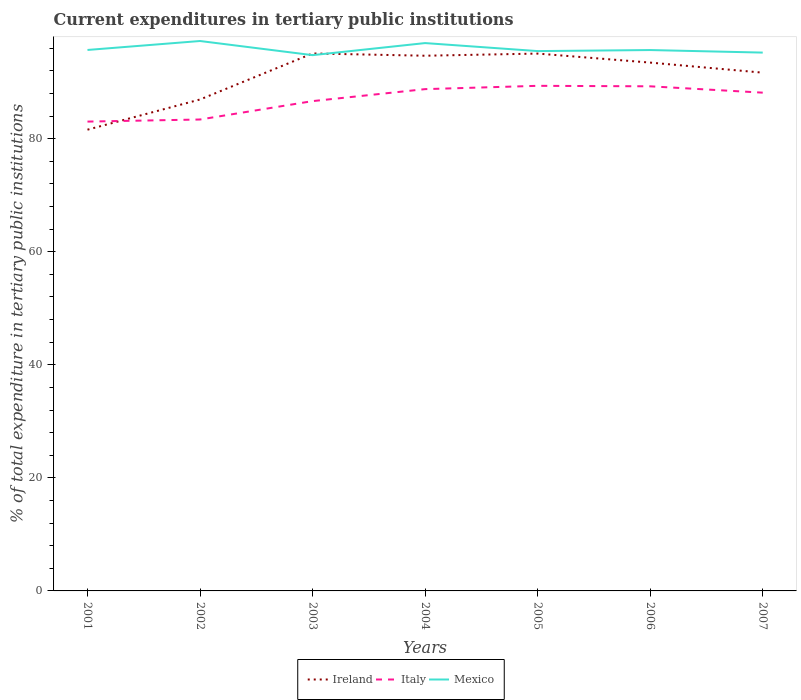How many different coloured lines are there?
Your answer should be compact. 3. Across all years, what is the maximum current expenditures in tertiary public institutions in Mexico?
Your response must be concise. 94.78. In which year was the current expenditures in tertiary public institutions in Ireland maximum?
Offer a very short reply. 2001. What is the total current expenditures in tertiary public institutions in Italy in the graph?
Give a very brief answer. -0.37. What is the difference between the highest and the second highest current expenditures in tertiary public institutions in Mexico?
Keep it short and to the point. 2.5. How many lines are there?
Your answer should be very brief. 3. What is the difference between two consecutive major ticks on the Y-axis?
Your answer should be compact. 20. Does the graph contain grids?
Offer a terse response. No. What is the title of the graph?
Offer a terse response. Current expenditures in tertiary public institutions. What is the label or title of the Y-axis?
Keep it short and to the point. % of total expenditure in tertiary public institutions. What is the % of total expenditure in tertiary public institutions in Ireland in 2001?
Your answer should be very brief. 81.6. What is the % of total expenditure in tertiary public institutions of Italy in 2001?
Your answer should be very brief. 83.03. What is the % of total expenditure in tertiary public institutions of Mexico in 2001?
Your answer should be compact. 95.7. What is the % of total expenditure in tertiary public institutions in Ireland in 2002?
Provide a short and direct response. 86.94. What is the % of total expenditure in tertiary public institutions in Italy in 2002?
Offer a terse response. 83.4. What is the % of total expenditure in tertiary public institutions in Mexico in 2002?
Give a very brief answer. 97.28. What is the % of total expenditure in tertiary public institutions of Ireland in 2003?
Give a very brief answer. 95.08. What is the % of total expenditure in tertiary public institutions in Italy in 2003?
Make the answer very short. 86.65. What is the % of total expenditure in tertiary public institutions of Mexico in 2003?
Give a very brief answer. 94.78. What is the % of total expenditure in tertiary public institutions of Ireland in 2004?
Keep it short and to the point. 94.68. What is the % of total expenditure in tertiary public institutions of Italy in 2004?
Ensure brevity in your answer.  88.77. What is the % of total expenditure in tertiary public institutions in Mexico in 2004?
Keep it short and to the point. 96.92. What is the % of total expenditure in tertiary public institutions in Ireland in 2005?
Make the answer very short. 95.06. What is the % of total expenditure in tertiary public institutions in Italy in 2005?
Offer a terse response. 89.36. What is the % of total expenditure in tertiary public institutions of Mexico in 2005?
Offer a very short reply. 95.5. What is the % of total expenditure in tertiary public institutions of Ireland in 2006?
Make the answer very short. 93.47. What is the % of total expenditure in tertiary public institutions in Italy in 2006?
Provide a short and direct response. 89.27. What is the % of total expenditure in tertiary public institutions in Mexico in 2006?
Offer a very short reply. 95.68. What is the % of total expenditure in tertiary public institutions in Ireland in 2007?
Give a very brief answer. 91.68. What is the % of total expenditure in tertiary public institutions of Italy in 2007?
Your answer should be very brief. 88.15. What is the % of total expenditure in tertiary public institutions of Mexico in 2007?
Make the answer very short. 95.23. Across all years, what is the maximum % of total expenditure in tertiary public institutions in Ireland?
Your answer should be compact. 95.08. Across all years, what is the maximum % of total expenditure in tertiary public institutions in Italy?
Give a very brief answer. 89.36. Across all years, what is the maximum % of total expenditure in tertiary public institutions in Mexico?
Give a very brief answer. 97.28. Across all years, what is the minimum % of total expenditure in tertiary public institutions of Ireland?
Make the answer very short. 81.6. Across all years, what is the minimum % of total expenditure in tertiary public institutions of Italy?
Ensure brevity in your answer.  83.03. Across all years, what is the minimum % of total expenditure in tertiary public institutions in Mexico?
Your answer should be compact. 94.78. What is the total % of total expenditure in tertiary public institutions of Ireland in the graph?
Your response must be concise. 638.51. What is the total % of total expenditure in tertiary public institutions in Italy in the graph?
Provide a short and direct response. 608.62. What is the total % of total expenditure in tertiary public institutions in Mexico in the graph?
Provide a succinct answer. 671.1. What is the difference between the % of total expenditure in tertiary public institutions of Ireland in 2001 and that in 2002?
Keep it short and to the point. -5.34. What is the difference between the % of total expenditure in tertiary public institutions in Italy in 2001 and that in 2002?
Your response must be concise. -0.37. What is the difference between the % of total expenditure in tertiary public institutions of Mexico in 2001 and that in 2002?
Your answer should be compact. -1.58. What is the difference between the % of total expenditure in tertiary public institutions of Ireland in 2001 and that in 2003?
Keep it short and to the point. -13.49. What is the difference between the % of total expenditure in tertiary public institutions of Italy in 2001 and that in 2003?
Ensure brevity in your answer.  -3.62. What is the difference between the % of total expenditure in tertiary public institutions of Mexico in 2001 and that in 2003?
Keep it short and to the point. 0.92. What is the difference between the % of total expenditure in tertiary public institutions in Ireland in 2001 and that in 2004?
Your response must be concise. -13.08. What is the difference between the % of total expenditure in tertiary public institutions of Italy in 2001 and that in 2004?
Offer a very short reply. -5.74. What is the difference between the % of total expenditure in tertiary public institutions in Mexico in 2001 and that in 2004?
Give a very brief answer. -1.22. What is the difference between the % of total expenditure in tertiary public institutions of Ireland in 2001 and that in 2005?
Offer a very short reply. -13.46. What is the difference between the % of total expenditure in tertiary public institutions in Italy in 2001 and that in 2005?
Ensure brevity in your answer.  -6.33. What is the difference between the % of total expenditure in tertiary public institutions in Mexico in 2001 and that in 2005?
Your answer should be very brief. 0.2. What is the difference between the % of total expenditure in tertiary public institutions in Ireland in 2001 and that in 2006?
Keep it short and to the point. -11.87. What is the difference between the % of total expenditure in tertiary public institutions of Italy in 2001 and that in 2006?
Offer a very short reply. -6.24. What is the difference between the % of total expenditure in tertiary public institutions of Mexico in 2001 and that in 2006?
Keep it short and to the point. 0.02. What is the difference between the % of total expenditure in tertiary public institutions in Ireland in 2001 and that in 2007?
Your answer should be very brief. -10.09. What is the difference between the % of total expenditure in tertiary public institutions of Italy in 2001 and that in 2007?
Provide a short and direct response. -5.12. What is the difference between the % of total expenditure in tertiary public institutions in Mexico in 2001 and that in 2007?
Your answer should be very brief. 0.47. What is the difference between the % of total expenditure in tertiary public institutions in Ireland in 2002 and that in 2003?
Your answer should be very brief. -8.14. What is the difference between the % of total expenditure in tertiary public institutions of Italy in 2002 and that in 2003?
Your response must be concise. -3.25. What is the difference between the % of total expenditure in tertiary public institutions in Mexico in 2002 and that in 2003?
Give a very brief answer. 2.5. What is the difference between the % of total expenditure in tertiary public institutions in Ireland in 2002 and that in 2004?
Provide a succinct answer. -7.74. What is the difference between the % of total expenditure in tertiary public institutions of Italy in 2002 and that in 2004?
Provide a succinct answer. -5.37. What is the difference between the % of total expenditure in tertiary public institutions of Mexico in 2002 and that in 2004?
Offer a terse response. 0.37. What is the difference between the % of total expenditure in tertiary public institutions in Ireland in 2002 and that in 2005?
Your answer should be very brief. -8.12. What is the difference between the % of total expenditure in tertiary public institutions of Italy in 2002 and that in 2005?
Ensure brevity in your answer.  -5.96. What is the difference between the % of total expenditure in tertiary public institutions of Mexico in 2002 and that in 2005?
Ensure brevity in your answer.  1.78. What is the difference between the % of total expenditure in tertiary public institutions of Ireland in 2002 and that in 2006?
Your response must be concise. -6.53. What is the difference between the % of total expenditure in tertiary public institutions in Italy in 2002 and that in 2006?
Offer a terse response. -5.87. What is the difference between the % of total expenditure in tertiary public institutions of Mexico in 2002 and that in 2006?
Your response must be concise. 1.6. What is the difference between the % of total expenditure in tertiary public institutions in Ireland in 2002 and that in 2007?
Provide a short and direct response. -4.74. What is the difference between the % of total expenditure in tertiary public institutions of Italy in 2002 and that in 2007?
Your response must be concise. -4.75. What is the difference between the % of total expenditure in tertiary public institutions of Mexico in 2002 and that in 2007?
Offer a very short reply. 2.05. What is the difference between the % of total expenditure in tertiary public institutions in Ireland in 2003 and that in 2004?
Provide a short and direct response. 0.4. What is the difference between the % of total expenditure in tertiary public institutions of Italy in 2003 and that in 2004?
Ensure brevity in your answer.  -2.12. What is the difference between the % of total expenditure in tertiary public institutions of Mexico in 2003 and that in 2004?
Your response must be concise. -2.13. What is the difference between the % of total expenditure in tertiary public institutions of Ireland in 2003 and that in 2005?
Provide a succinct answer. 0.02. What is the difference between the % of total expenditure in tertiary public institutions of Italy in 2003 and that in 2005?
Make the answer very short. -2.7. What is the difference between the % of total expenditure in tertiary public institutions of Mexico in 2003 and that in 2005?
Keep it short and to the point. -0.72. What is the difference between the % of total expenditure in tertiary public institutions in Ireland in 2003 and that in 2006?
Make the answer very short. 1.62. What is the difference between the % of total expenditure in tertiary public institutions of Italy in 2003 and that in 2006?
Give a very brief answer. -2.62. What is the difference between the % of total expenditure in tertiary public institutions in Mexico in 2003 and that in 2006?
Offer a terse response. -0.9. What is the difference between the % of total expenditure in tertiary public institutions in Ireland in 2003 and that in 2007?
Keep it short and to the point. 3.4. What is the difference between the % of total expenditure in tertiary public institutions of Italy in 2003 and that in 2007?
Your response must be concise. -1.5. What is the difference between the % of total expenditure in tertiary public institutions in Mexico in 2003 and that in 2007?
Keep it short and to the point. -0.45. What is the difference between the % of total expenditure in tertiary public institutions in Ireland in 2004 and that in 2005?
Your answer should be compact. -0.38. What is the difference between the % of total expenditure in tertiary public institutions of Italy in 2004 and that in 2005?
Ensure brevity in your answer.  -0.59. What is the difference between the % of total expenditure in tertiary public institutions of Mexico in 2004 and that in 2005?
Keep it short and to the point. 1.42. What is the difference between the % of total expenditure in tertiary public institutions of Ireland in 2004 and that in 2006?
Ensure brevity in your answer.  1.21. What is the difference between the % of total expenditure in tertiary public institutions of Italy in 2004 and that in 2006?
Your answer should be compact. -0.5. What is the difference between the % of total expenditure in tertiary public institutions in Mexico in 2004 and that in 2006?
Your answer should be compact. 1.23. What is the difference between the % of total expenditure in tertiary public institutions of Ireland in 2004 and that in 2007?
Give a very brief answer. 3. What is the difference between the % of total expenditure in tertiary public institutions of Italy in 2004 and that in 2007?
Offer a very short reply. 0.62. What is the difference between the % of total expenditure in tertiary public institutions in Mexico in 2004 and that in 2007?
Provide a short and direct response. 1.68. What is the difference between the % of total expenditure in tertiary public institutions in Ireland in 2005 and that in 2006?
Keep it short and to the point. 1.59. What is the difference between the % of total expenditure in tertiary public institutions of Italy in 2005 and that in 2006?
Your answer should be compact. 0.09. What is the difference between the % of total expenditure in tertiary public institutions of Mexico in 2005 and that in 2006?
Your answer should be very brief. -0.18. What is the difference between the % of total expenditure in tertiary public institutions in Ireland in 2005 and that in 2007?
Ensure brevity in your answer.  3.38. What is the difference between the % of total expenditure in tertiary public institutions of Italy in 2005 and that in 2007?
Offer a very short reply. 1.21. What is the difference between the % of total expenditure in tertiary public institutions in Mexico in 2005 and that in 2007?
Offer a very short reply. 0.27. What is the difference between the % of total expenditure in tertiary public institutions in Ireland in 2006 and that in 2007?
Your answer should be very brief. 1.78. What is the difference between the % of total expenditure in tertiary public institutions in Italy in 2006 and that in 2007?
Provide a short and direct response. 1.12. What is the difference between the % of total expenditure in tertiary public institutions of Mexico in 2006 and that in 2007?
Your response must be concise. 0.45. What is the difference between the % of total expenditure in tertiary public institutions of Ireland in 2001 and the % of total expenditure in tertiary public institutions of Italy in 2002?
Offer a terse response. -1.8. What is the difference between the % of total expenditure in tertiary public institutions in Ireland in 2001 and the % of total expenditure in tertiary public institutions in Mexico in 2002?
Your answer should be compact. -15.69. What is the difference between the % of total expenditure in tertiary public institutions in Italy in 2001 and the % of total expenditure in tertiary public institutions in Mexico in 2002?
Provide a short and direct response. -14.26. What is the difference between the % of total expenditure in tertiary public institutions of Ireland in 2001 and the % of total expenditure in tertiary public institutions of Italy in 2003?
Your answer should be compact. -5.05. What is the difference between the % of total expenditure in tertiary public institutions of Ireland in 2001 and the % of total expenditure in tertiary public institutions of Mexico in 2003?
Give a very brief answer. -13.19. What is the difference between the % of total expenditure in tertiary public institutions in Italy in 2001 and the % of total expenditure in tertiary public institutions in Mexico in 2003?
Make the answer very short. -11.76. What is the difference between the % of total expenditure in tertiary public institutions in Ireland in 2001 and the % of total expenditure in tertiary public institutions in Italy in 2004?
Your answer should be compact. -7.17. What is the difference between the % of total expenditure in tertiary public institutions of Ireland in 2001 and the % of total expenditure in tertiary public institutions of Mexico in 2004?
Your response must be concise. -15.32. What is the difference between the % of total expenditure in tertiary public institutions of Italy in 2001 and the % of total expenditure in tertiary public institutions of Mexico in 2004?
Keep it short and to the point. -13.89. What is the difference between the % of total expenditure in tertiary public institutions of Ireland in 2001 and the % of total expenditure in tertiary public institutions of Italy in 2005?
Your response must be concise. -7.76. What is the difference between the % of total expenditure in tertiary public institutions in Ireland in 2001 and the % of total expenditure in tertiary public institutions in Mexico in 2005?
Give a very brief answer. -13.9. What is the difference between the % of total expenditure in tertiary public institutions in Italy in 2001 and the % of total expenditure in tertiary public institutions in Mexico in 2005?
Your response must be concise. -12.47. What is the difference between the % of total expenditure in tertiary public institutions in Ireland in 2001 and the % of total expenditure in tertiary public institutions in Italy in 2006?
Offer a very short reply. -7.67. What is the difference between the % of total expenditure in tertiary public institutions of Ireland in 2001 and the % of total expenditure in tertiary public institutions of Mexico in 2006?
Ensure brevity in your answer.  -14.09. What is the difference between the % of total expenditure in tertiary public institutions of Italy in 2001 and the % of total expenditure in tertiary public institutions of Mexico in 2006?
Provide a short and direct response. -12.66. What is the difference between the % of total expenditure in tertiary public institutions of Ireland in 2001 and the % of total expenditure in tertiary public institutions of Italy in 2007?
Provide a succinct answer. -6.55. What is the difference between the % of total expenditure in tertiary public institutions of Ireland in 2001 and the % of total expenditure in tertiary public institutions of Mexico in 2007?
Provide a succinct answer. -13.64. What is the difference between the % of total expenditure in tertiary public institutions in Italy in 2001 and the % of total expenditure in tertiary public institutions in Mexico in 2007?
Offer a very short reply. -12.21. What is the difference between the % of total expenditure in tertiary public institutions of Ireland in 2002 and the % of total expenditure in tertiary public institutions of Italy in 2003?
Your answer should be very brief. 0.29. What is the difference between the % of total expenditure in tertiary public institutions of Ireland in 2002 and the % of total expenditure in tertiary public institutions of Mexico in 2003?
Ensure brevity in your answer.  -7.84. What is the difference between the % of total expenditure in tertiary public institutions in Italy in 2002 and the % of total expenditure in tertiary public institutions in Mexico in 2003?
Your response must be concise. -11.39. What is the difference between the % of total expenditure in tertiary public institutions of Ireland in 2002 and the % of total expenditure in tertiary public institutions of Italy in 2004?
Give a very brief answer. -1.83. What is the difference between the % of total expenditure in tertiary public institutions in Ireland in 2002 and the % of total expenditure in tertiary public institutions in Mexico in 2004?
Your answer should be very brief. -9.98. What is the difference between the % of total expenditure in tertiary public institutions of Italy in 2002 and the % of total expenditure in tertiary public institutions of Mexico in 2004?
Provide a short and direct response. -13.52. What is the difference between the % of total expenditure in tertiary public institutions in Ireland in 2002 and the % of total expenditure in tertiary public institutions in Italy in 2005?
Give a very brief answer. -2.42. What is the difference between the % of total expenditure in tertiary public institutions of Ireland in 2002 and the % of total expenditure in tertiary public institutions of Mexico in 2005?
Make the answer very short. -8.56. What is the difference between the % of total expenditure in tertiary public institutions in Italy in 2002 and the % of total expenditure in tertiary public institutions in Mexico in 2005?
Keep it short and to the point. -12.1. What is the difference between the % of total expenditure in tertiary public institutions in Ireland in 2002 and the % of total expenditure in tertiary public institutions in Italy in 2006?
Your response must be concise. -2.33. What is the difference between the % of total expenditure in tertiary public institutions in Ireland in 2002 and the % of total expenditure in tertiary public institutions in Mexico in 2006?
Keep it short and to the point. -8.74. What is the difference between the % of total expenditure in tertiary public institutions of Italy in 2002 and the % of total expenditure in tertiary public institutions of Mexico in 2006?
Keep it short and to the point. -12.29. What is the difference between the % of total expenditure in tertiary public institutions of Ireland in 2002 and the % of total expenditure in tertiary public institutions of Italy in 2007?
Ensure brevity in your answer.  -1.21. What is the difference between the % of total expenditure in tertiary public institutions of Ireland in 2002 and the % of total expenditure in tertiary public institutions of Mexico in 2007?
Your answer should be compact. -8.29. What is the difference between the % of total expenditure in tertiary public institutions in Italy in 2002 and the % of total expenditure in tertiary public institutions in Mexico in 2007?
Make the answer very short. -11.84. What is the difference between the % of total expenditure in tertiary public institutions in Ireland in 2003 and the % of total expenditure in tertiary public institutions in Italy in 2004?
Keep it short and to the point. 6.31. What is the difference between the % of total expenditure in tertiary public institutions in Ireland in 2003 and the % of total expenditure in tertiary public institutions in Mexico in 2004?
Your answer should be very brief. -1.84. What is the difference between the % of total expenditure in tertiary public institutions in Italy in 2003 and the % of total expenditure in tertiary public institutions in Mexico in 2004?
Your answer should be compact. -10.27. What is the difference between the % of total expenditure in tertiary public institutions of Ireland in 2003 and the % of total expenditure in tertiary public institutions of Italy in 2005?
Ensure brevity in your answer.  5.73. What is the difference between the % of total expenditure in tertiary public institutions in Ireland in 2003 and the % of total expenditure in tertiary public institutions in Mexico in 2005?
Your answer should be compact. -0.42. What is the difference between the % of total expenditure in tertiary public institutions of Italy in 2003 and the % of total expenditure in tertiary public institutions of Mexico in 2005?
Offer a terse response. -8.85. What is the difference between the % of total expenditure in tertiary public institutions in Ireland in 2003 and the % of total expenditure in tertiary public institutions in Italy in 2006?
Offer a very short reply. 5.81. What is the difference between the % of total expenditure in tertiary public institutions of Ireland in 2003 and the % of total expenditure in tertiary public institutions of Mexico in 2006?
Your answer should be very brief. -0.6. What is the difference between the % of total expenditure in tertiary public institutions of Italy in 2003 and the % of total expenditure in tertiary public institutions of Mexico in 2006?
Ensure brevity in your answer.  -9.03. What is the difference between the % of total expenditure in tertiary public institutions of Ireland in 2003 and the % of total expenditure in tertiary public institutions of Italy in 2007?
Provide a short and direct response. 6.93. What is the difference between the % of total expenditure in tertiary public institutions of Ireland in 2003 and the % of total expenditure in tertiary public institutions of Mexico in 2007?
Provide a short and direct response. -0.15. What is the difference between the % of total expenditure in tertiary public institutions in Italy in 2003 and the % of total expenditure in tertiary public institutions in Mexico in 2007?
Offer a very short reply. -8.58. What is the difference between the % of total expenditure in tertiary public institutions of Ireland in 2004 and the % of total expenditure in tertiary public institutions of Italy in 2005?
Your answer should be very brief. 5.32. What is the difference between the % of total expenditure in tertiary public institutions in Ireland in 2004 and the % of total expenditure in tertiary public institutions in Mexico in 2005?
Provide a short and direct response. -0.82. What is the difference between the % of total expenditure in tertiary public institutions of Italy in 2004 and the % of total expenditure in tertiary public institutions of Mexico in 2005?
Ensure brevity in your answer.  -6.73. What is the difference between the % of total expenditure in tertiary public institutions of Ireland in 2004 and the % of total expenditure in tertiary public institutions of Italy in 2006?
Provide a succinct answer. 5.41. What is the difference between the % of total expenditure in tertiary public institutions of Ireland in 2004 and the % of total expenditure in tertiary public institutions of Mexico in 2006?
Your response must be concise. -1. What is the difference between the % of total expenditure in tertiary public institutions in Italy in 2004 and the % of total expenditure in tertiary public institutions in Mexico in 2006?
Offer a very short reply. -6.91. What is the difference between the % of total expenditure in tertiary public institutions in Ireland in 2004 and the % of total expenditure in tertiary public institutions in Italy in 2007?
Provide a succinct answer. 6.53. What is the difference between the % of total expenditure in tertiary public institutions in Ireland in 2004 and the % of total expenditure in tertiary public institutions in Mexico in 2007?
Keep it short and to the point. -0.55. What is the difference between the % of total expenditure in tertiary public institutions of Italy in 2004 and the % of total expenditure in tertiary public institutions of Mexico in 2007?
Your response must be concise. -6.46. What is the difference between the % of total expenditure in tertiary public institutions of Ireland in 2005 and the % of total expenditure in tertiary public institutions of Italy in 2006?
Provide a short and direct response. 5.79. What is the difference between the % of total expenditure in tertiary public institutions in Ireland in 2005 and the % of total expenditure in tertiary public institutions in Mexico in 2006?
Keep it short and to the point. -0.62. What is the difference between the % of total expenditure in tertiary public institutions of Italy in 2005 and the % of total expenditure in tertiary public institutions of Mexico in 2006?
Offer a terse response. -6.33. What is the difference between the % of total expenditure in tertiary public institutions in Ireland in 2005 and the % of total expenditure in tertiary public institutions in Italy in 2007?
Keep it short and to the point. 6.91. What is the difference between the % of total expenditure in tertiary public institutions in Ireland in 2005 and the % of total expenditure in tertiary public institutions in Mexico in 2007?
Ensure brevity in your answer.  -0.17. What is the difference between the % of total expenditure in tertiary public institutions of Italy in 2005 and the % of total expenditure in tertiary public institutions of Mexico in 2007?
Offer a terse response. -5.88. What is the difference between the % of total expenditure in tertiary public institutions in Ireland in 2006 and the % of total expenditure in tertiary public institutions in Italy in 2007?
Give a very brief answer. 5.32. What is the difference between the % of total expenditure in tertiary public institutions in Ireland in 2006 and the % of total expenditure in tertiary public institutions in Mexico in 2007?
Offer a terse response. -1.77. What is the difference between the % of total expenditure in tertiary public institutions in Italy in 2006 and the % of total expenditure in tertiary public institutions in Mexico in 2007?
Keep it short and to the point. -5.97. What is the average % of total expenditure in tertiary public institutions in Ireland per year?
Ensure brevity in your answer.  91.22. What is the average % of total expenditure in tertiary public institutions of Italy per year?
Offer a very short reply. 86.95. What is the average % of total expenditure in tertiary public institutions of Mexico per year?
Provide a succinct answer. 95.87. In the year 2001, what is the difference between the % of total expenditure in tertiary public institutions of Ireland and % of total expenditure in tertiary public institutions of Italy?
Make the answer very short. -1.43. In the year 2001, what is the difference between the % of total expenditure in tertiary public institutions in Ireland and % of total expenditure in tertiary public institutions in Mexico?
Provide a succinct answer. -14.1. In the year 2001, what is the difference between the % of total expenditure in tertiary public institutions in Italy and % of total expenditure in tertiary public institutions in Mexico?
Offer a terse response. -12.67. In the year 2002, what is the difference between the % of total expenditure in tertiary public institutions of Ireland and % of total expenditure in tertiary public institutions of Italy?
Offer a terse response. 3.54. In the year 2002, what is the difference between the % of total expenditure in tertiary public institutions in Ireland and % of total expenditure in tertiary public institutions in Mexico?
Ensure brevity in your answer.  -10.34. In the year 2002, what is the difference between the % of total expenditure in tertiary public institutions of Italy and % of total expenditure in tertiary public institutions of Mexico?
Provide a short and direct response. -13.89. In the year 2003, what is the difference between the % of total expenditure in tertiary public institutions of Ireland and % of total expenditure in tertiary public institutions of Italy?
Give a very brief answer. 8.43. In the year 2003, what is the difference between the % of total expenditure in tertiary public institutions in Ireland and % of total expenditure in tertiary public institutions in Mexico?
Offer a very short reply. 0.3. In the year 2003, what is the difference between the % of total expenditure in tertiary public institutions of Italy and % of total expenditure in tertiary public institutions of Mexico?
Your answer should be compact. -8.13. In the year 2004, what is the difference between the % of total expenditure in tertiary public institutions in Ireland and % of total expenditure in tertiary public institutions in Italy?
Your response must be concise. 5.91. In the year 2004, what is the difference between the % of total expenditure in tertiary public institutions of Ireland and % of total expenditure in tertiary public institutions of Mexico?
Offer a very short reply. -2.24. In the year 2004, what is the difference between the % of total expenditure in tertiary public institutions in Italy and % of total expenditure in tertiary public institutions in Mexico?
Provide a succinct answer. -8.15. In the year 2005, what is the difference between the % of total expenditure in tertiary public institutions of Ireland and % of total expenditure in tertiary public institutions of Italy?
Provide a short and direct response. 5.7. In the year 2005, what is the difference between the % of total expenditure in tertiary public institutions of Ireland and % of total expenditure in tertiary public institutions of Mexico?
Keep it short and to the point. -0.44. In the year 2005, what is the difference between the % of total expenditure in tertiary public institutions of Italy and % of total expenditure in tertiary public institutions of Mexico?
Ensure brevity in your answer.  -6.14. In the year 2006, what is the difference between the % of total expenditure in tertiary public institutions in Ireland and % of total expenditure in tertiary public institutions in Italy?
Your response must be concise. 4.2. In the year 2006, what is the difference between the % of total expenditure in tertiary public institutions of Ireland and % of total expenditure in tertiary public institutions of Mexico?
Provide a short and direct response. -2.22. In the year 2006, what is the difference between the % of total expenditure in tertiary public institutions of Italy and % of total expenditure in tertiary public institutions of Mexico?
Your answer should be very brief. -6.41. In the year 2007, what is the difference between the % of total expenditure in tertiary public institutions of Ireland and % of total expenditure in tertiary public institutions of Italy?
Give a very brief answer. 3.54. In the year 2007, what is the difference between the % of total expenditure in tertiary public institutions of Ireland and % of total expenditure in tertiary public institutions of Mexico?
Offer a very short reply. -3.55. In the year 2007, what is the difference between the % of total expenditure in tertiary public institutions of Italy and % of total expenditure in tertiary public institutions of Mexico?
Offer a very short reply. -7.09. What is the ratio of the % of total expenditure in tertiary public institutions in Ireland in 2001 to that in 2002?
Your answer should be very brief. 0.94. What is the ratio of the % of total expenditure in tertiary public institutions of Italy in 2001 to that in 2002?
Ensure brevity in your answer.  1. What is the ratio of the % of total expenditure in tertiary public institutions of Mexico in 2001 to that in 2002?
Offer a very short reply. 0.98. What is the ratio of the % of total expenditure in tertiary public institutions of Ireland in 2001 to that in 2003?
Provide a succinct answer. 0.86. What is the ratio of the % of total expenditure in tertiary public institutions of Italy in 2001 to that in 2003?
Provide a succinct answer. 0.96. What is the ratio of the % of total expenditure in tertiary public institutions of Mexico in 2001 to that in 2003?
Make the answer very short. 1.01. What is the ratio of the % of total expenditure in tertiary public institutions of Ireland in 2001 to that in 2004?
Offer a terse response. 0.86. What is the ratio of the % of total expenditure in tertiary public institutions of Italy in 2001 to that in 2004?
Your answer should be very brief. 0.94. What is the ratio of the % of total expenditure in tertiary public institutions in Mexico in 2001 to that in 2004?
Ensure brevity in your answer.  0.99. What is the ratio of the % of total expenditure in tertiary public institutions in Ireland in 2001 to that in 2005?
Provide a succinct answer. 0.86. What is the ratio of the % of total expenditure in tertiary public institutions of Italy in 2001 to that in 2005?
Offer a terse response. 0.93. What is the ratio of the % of total expenditure in tertiary public institutions of Ireland in 2001 to that in 2006?
Offer a terse response. 0.87. What is the ratio of the % of total expenditure in tertiary public institutions in Italy in 2001 to that in 2006?
Make the answer very short. 0.93. What is the ratio of the % of total expenditure in tertiary public institutions in Ireland in 2001 to that in 2007?
Provide a short and direct response. 0.89. What is the ratio of the % of total expenditure in tertiary public institutions in Italy in 2001 to that in 2007?
Make the answer very short. 0.94. What is the ratio of the % of total expenditure in tertiary public institutions of Ireland in 2002 to that in 2003?
Your answer should be very brief. 0.91. What is the ratio of the % of total expenditure in tertiary public institutions in Italy in 2002 to that in 2003?
Give a very brief answer. 0.96. What is the ratio of the % of total expenditure in tertiary public institutions of Mexico in 2002 to that in 2003?
Your answer should be compact. 1.03. What is the ratio of the % of total expenditure in tertiary public institutions in Ireland in 2002 to that in 2004?
Your response must be concise. 0.92. What is the ratio of the % of total expenditure in tertiary public institutions in Italy in 2002 to that in 2004?
Your response must be concise. 0.94. What is the ratio of the % of total expenditure in tertiary public institutions of Mexico in 2002 to that in 2004?
Keep it short and to the point. 1. What is the ratio of the % of total expenditure in tertiary public institutions of Ireland in 2002 to that in 2005?
Ensure brevity in your answer.  0.91. What is the ratio of the % of total expenditure in tertiary public institutions of Mexico in 2002 to that in 2005?
Your answer should be very brief. 1.02. What is the ratio of the % of total expenditure in tertiary public institutions in Ireland in 2002 to that in 2006?
Keep it short and to the point. 0.93. What is the ratio of the % of total expenditure in tertiary public institutions in Italy in 2002 to that in 2006?
Offer a terse response. 0.93. What is the ratio of the % of total expenditure in tertiary public institutions in Mexico in 2002 to that in 2006?
Provide a succinct answer. 1.02. What is the ratio of the % of total expenditure in tertiary public institutions in Ireland in 2002 to that in 2007?
Your response must be concise. 0.95. What is the ratio of the % of total expenditure in tertiary public institutions in Italy in 2002 to that in 2007?
Make the answer very short. 0.95. What is the ratio of the % of total expenditure in tertiary public institutions in Mexico in 2002 to that in 2007?
Offer a very short reply. 1.02. What is the ratio of the % of total expenditure in tertiary public institutions in Ireland in 2003 to that in 2004?
Provide a succinct answer. 1. What is the ratio of the % of total expenditure in tertiary public institutions in Italy in 2003 to that in 2004?
Your response must be concise. 0.98. What is the ratio of the % of total expenditure in tertiary public institutions in Mexico in 2003 to that in 2004?
Your response must be concise. 0.98. What is the ratio of the % of total expenditure in tertiary public institutions of Italy in 2003 to that in 2005?
Give a very brief answer. 0.97. What is the ratio of the % of total expenditure in tertiary public institutions of Ireland in 2003 to that in 2006?
Offer a very short reply. 1.02. What is the ratio of the % of total expenditure in tertiary public institutions of Italy in 2003 to that in 2006?
Give a very brief answer. 0.97. What is the ratio of the % of total expenditure in tertiary public institutions of Mexico in 2003 to that in 2006?
Offer a very short reply. 0.99. What is the ratio of the % of total expenditure in tertiary public institutions in Ireland in 2003 to that in 2007?
Offer a very short reply. 1.04. What is the ratio of the % of total expenditure in tertiary public institutions of Italy in 2003 to that in 2007?
Your answer should be compact. 0.98. What is the ratio of the % of total expenditure in tertiary public institutions in Ireland in 2004 to that in 2005?
Your response must be concise. 1. What is the ratio of the % of total expenditure in tertiary public institutions of Mexico in 2004 to that in 2005?
Ensure brevity in your answer.  1.01. What is the ratio of the % of total expenditure in tertiary public institutions of Ireland in 2004 to that in 2006?
Provide a short and direct response. 1.01. What is the ratio of the % of total expenditure in tertiary public institutions in Mexico in 2004 to that in 2006?
Provide a short and direct response. 1.01. What is the ratio of the % of total expenditure in tertiary public institutions of Ireland in 2004 to that in 2007?
Offer a terse response. 1.03. What is the ratio of the % of total expenditure in tertiary public institutions of Italy in 2004 to that in 2007?
Keep it short and to the point. 1.01. What is the ratio of the % of total expenditure in tertiary public institutions in Mexico in 2004 to that in 2007?
Offer a terse response. 1.02. What is the ratio of the % of total expenditure in tertiary public institutions in Ireland in 2005 to that in 2006?
Your response must be concise. 1.02. What is the ratio of the % of total expenditure in tertiary public institutions of Italy in 2005 to that in 2006?
Provide a succinct answer. 1. What is the ratio of the % of total expenditure in tertiary public institutions of Mexico in 2005 to that in 2006?
Your answer should be very brief. 1. What is the ratio of the % of total expenditure in tertiary public institutions in Ireland in 2005 to that in 2007?
Make the answer very short. 1.04. What is the ratio of the % of total expenditure in tertiary public institutions of Italy in 2005 to that in 2007?
Offer a very short reply. 1.01. What is the ratio of the % of total expenditure in tertiary public institutions of Ireland in 2006 to that in 2007?
Your response must be concise. 1.02. What is the ratio of the % of total expenditure in tertiary public institutions of Italy in 2006 to that in 2007?
Your response must be concise. 1.01. What is the difference between the highest and the second highest % of total expenditure in tertiary public institutions in Ireland?
Your answer should be compact. 0.02. What is the difference between the highest and the second highest % of total expenditure in tertiary public institutions of Italy?
Keep it short and to the point. 0.09. What is the difference between the highest and the second highest % of total expenditure in tertiary public institutions in Mexico?
Keep it short and to the point. 0.37. What is the difference between the highest and the lowest % of total expenditure in tertiary public institutions in Ireland?
Keep it short and to the point. 13.49. What is the difference between the highest and the lowest % of total expenditure in tertiary public institutions in Italy?
Your answer should be very brief. 6.33. What is the difference between the highest and the lowest % of total expenditure in tertiary public institutions of Mexico?
Your answer should be compact. 2.5. 